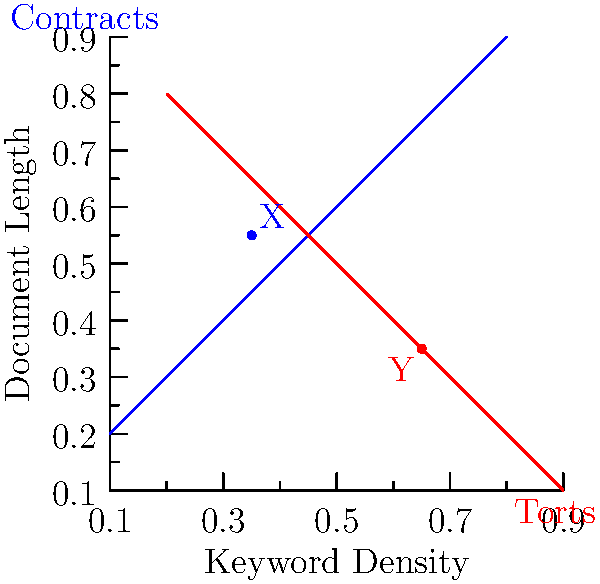In the scatter plot above, two types of legal documents are represented: contracts (blue) and torts (red). The x-axis represents keyword density, and the y-axis represents document length. Given this visualization, which of the following statements is most accurate regarding documents X and Y? To answer this question, we need to analyze the positions of points X and Y in relation to the clusters representing contracts and torts:

1. Document X (blue dot):
   - Located at approximately (0.35, 0.55) on the graph
   - Positioned closer to the blue cluster (contracts)
   - Has a lower keyword density and medium document length

2. Document Y (red dot):
   - Located at approximately (0.65, 0.35) on the graph
   - Positioned closer to the red cluster (torts)
   - Has a higher keyword density and shorter document length

3. Comparing the clusters:
   - Contracts (blue) tend to have lower keyword density and longer document length
   - Torts (red) tend to have higher keyword density and shorter document length

4. Analyzing the positions:
   - Document X aligns more closely with the characteristics of contracts
   - Document Y aligns more closely with the characteristics of torts

5. Conclusion:
   Based on their positions in the scatter plot, document X is more likely to be a contract, while document Y is more likely to be a tort document.
Answer: Document X is likely a contract, and document Y is likely a tort. 